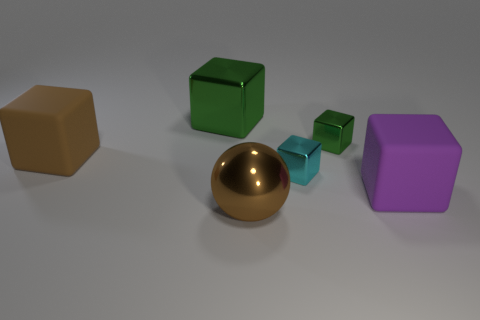Are there any other things that are the same size as the brown ball?
Offer a very short reply. Yes. There is another tiny thing that is the same shape as the cyan metallic object; what is its color?
Offer a terse response. Green. The object that is both behind the small cyan thing and on the right side of the large green metallic cube is made of what material?
Give a very brief answer. Metal. Is the number of big brown objects behind the large metallic sphere greater than the number of spheres that are behind the small cyan shiny block?
Give a very brief answer. Yes. There is a small thing that is in front of the brown cube; what color is it?
Give a very brief answer. Cyan. Does the rubber cube behind the purple thing have the same size as the metallic cube that is in front of the big brown matte cube?
Keep it short and to the point. No. What number of things are big purple matte things or big red matte balls?
Keep it short and to the point. 1. There is a big block that is to the left of the metallic cube left of the brown ball; what is its material?
Ensure brevity in your answer.  Rubber. What number of tiny cyan rubber things have the same shape as the cyan shiny object?
Ensure brevity in your answer.  0. Are there any large cubes of the same color as the big sphere?
Offer a terse response. Yes. 